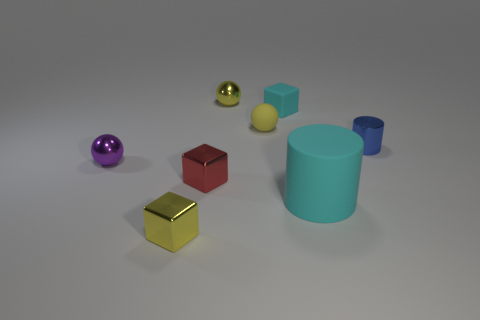Is the size of the purple shiny sphere the same as the red shiny block?
Make the answer very short. Yes. Is the number of matte cubes to the left of the tiny purple shiny thing less than the number of tiny shiny things that are on the left side of the small blue shiny thing?
Offer a terse response. Yes. Is there anything else that is the same size as the cyan cylinder?
Ensure brevity in your answer.  No. What size is the matte cylinder?
Provide a succinct answer. Large. What number of tiny things are either yellow metallic objects or cyan matte cylinders?
Offer a terse response. 2. There is a matte cylinder; is it the same size as the yellow object in front of the red metal object?
Provide a short and direct response. No. How many yellow metallic spheres are there?
Provide a short and direct response. 1. What number of yellow things are tiny matte spheres or big metallic objects?
Your answer should be very brief. 1. Is the material of the tiny object behind the tiny cyan thing the same as the big cylinder?
Keep it short and to the point. No. What number of other things are there of the same material as the tiny yellow cube
Provide a short and direct response. 4. 